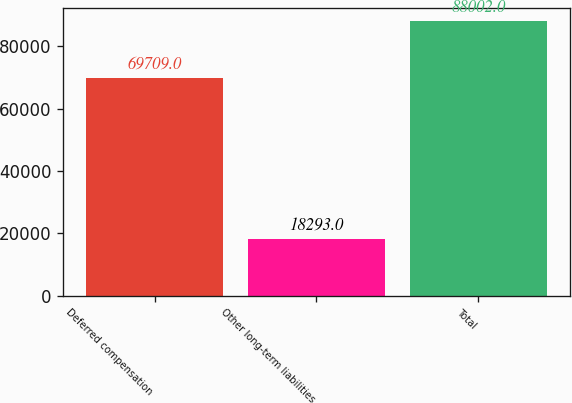<chart> <loc_0><loc_0><loc_500><loc_500><bar_chart><fcel>Deferred compensation<fcel>Other long-term liabilities<fcel>Total<nl><fcel>69709<fcel>18293<fcel>88002<nl></chart> 